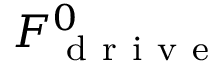Convert formula to latex. <formula><loc_0><loc_0><loc_500><loc_500>F _ { d r i v e } ^ { 0 }</formula> 